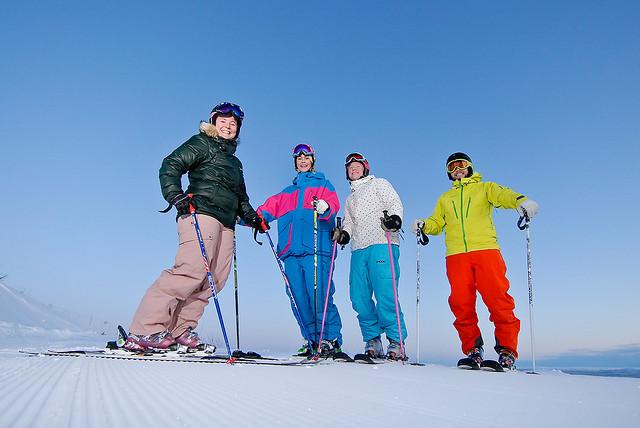How many people are in the photo?
Keep it brief. 4. How many skies are there?
Keep it brief. 8. Who has the more colorful outfit?
Give a very brief answer. Man on right. How cold is it outside?
Concise answer only. Very. 